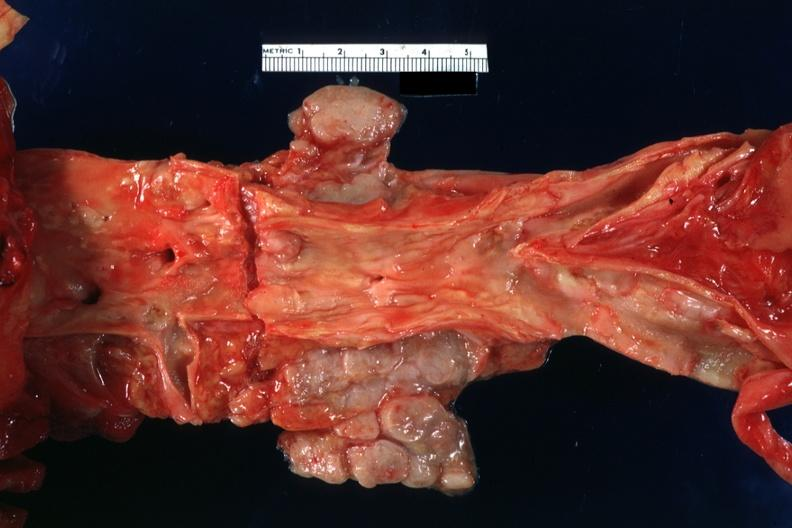how does this image show enlarged periaortic nodes?
Answer the question using a single word or phrase. With homogeneous tan tumor primary malignant carcinoid in jejunum 